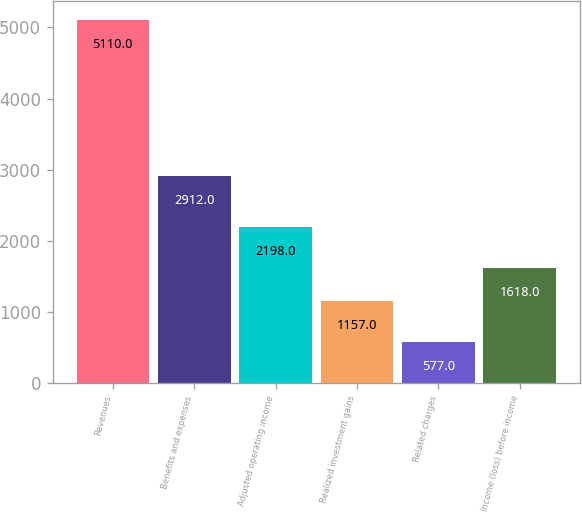<chart> <loc_0><loc_0><loc_500><loc_500><bar_chart><fcel>Revenues<fcel>Benefits and expenses<fcel>Adjusted operating income<fcel>Realized investment gains<fcel>Related charges<fcel>Income (loss) before income<nl><fcel>5110<fcel>2912<fcel>2198<fcel>1157<fcel>577<fcel>1618<nl></chart> 